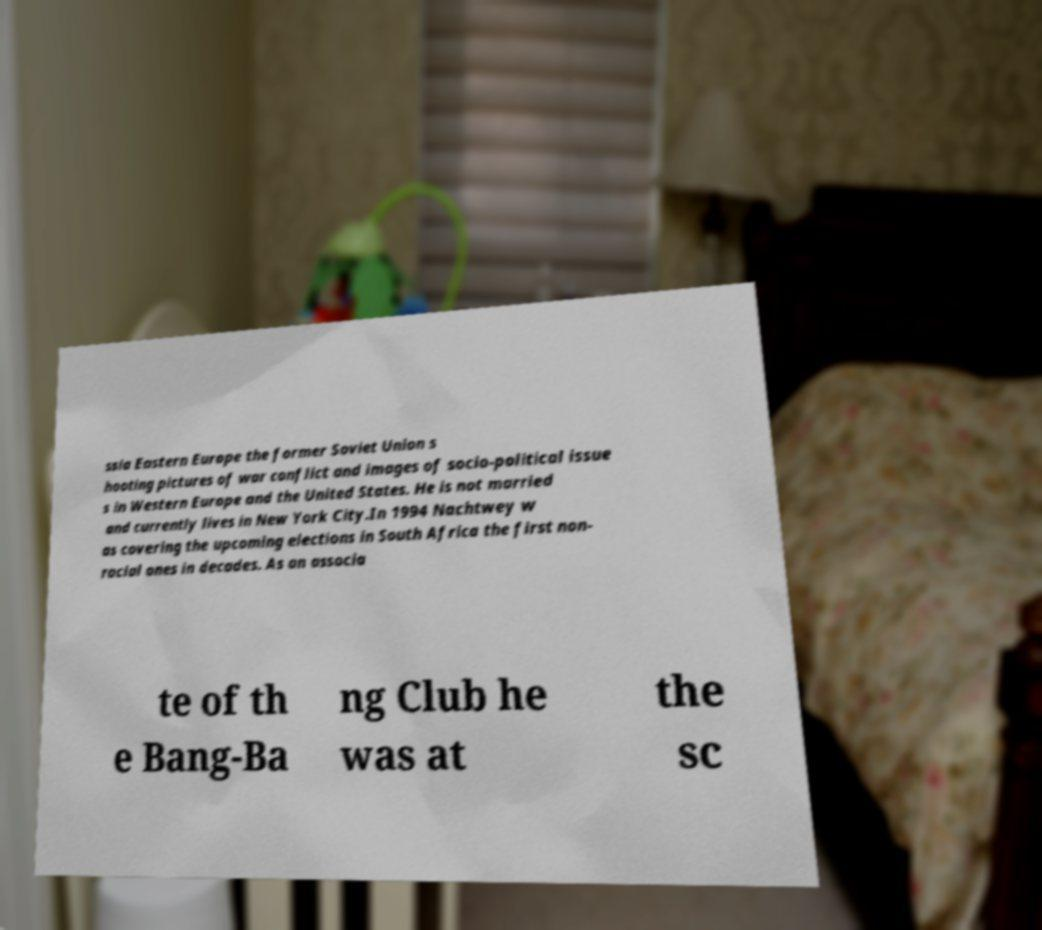For documentation purposes, I need the text within this image transcribed. Could you provide that? ssia Eastern Europe the former Soviet Union s hooting pictures of war conflict and images of socio-political issue s in Western Europe and the United States. He is not married and currently lives in New York City.In 1994 Nachtwey w as covering the upcoming elections in South Africa the first non- racial ones in decades. As an associa te of th e Bang-Ba ng Club he was at the sc 